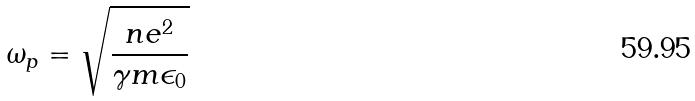Convert formula to latex. <formula><loc_0><loc_0><loc_500><loc_500>\omega _ { p } = \sqrt { \frac { n e ^ { 2 } } { \gamma m \epsilon _ { 0 } } }</formula> 